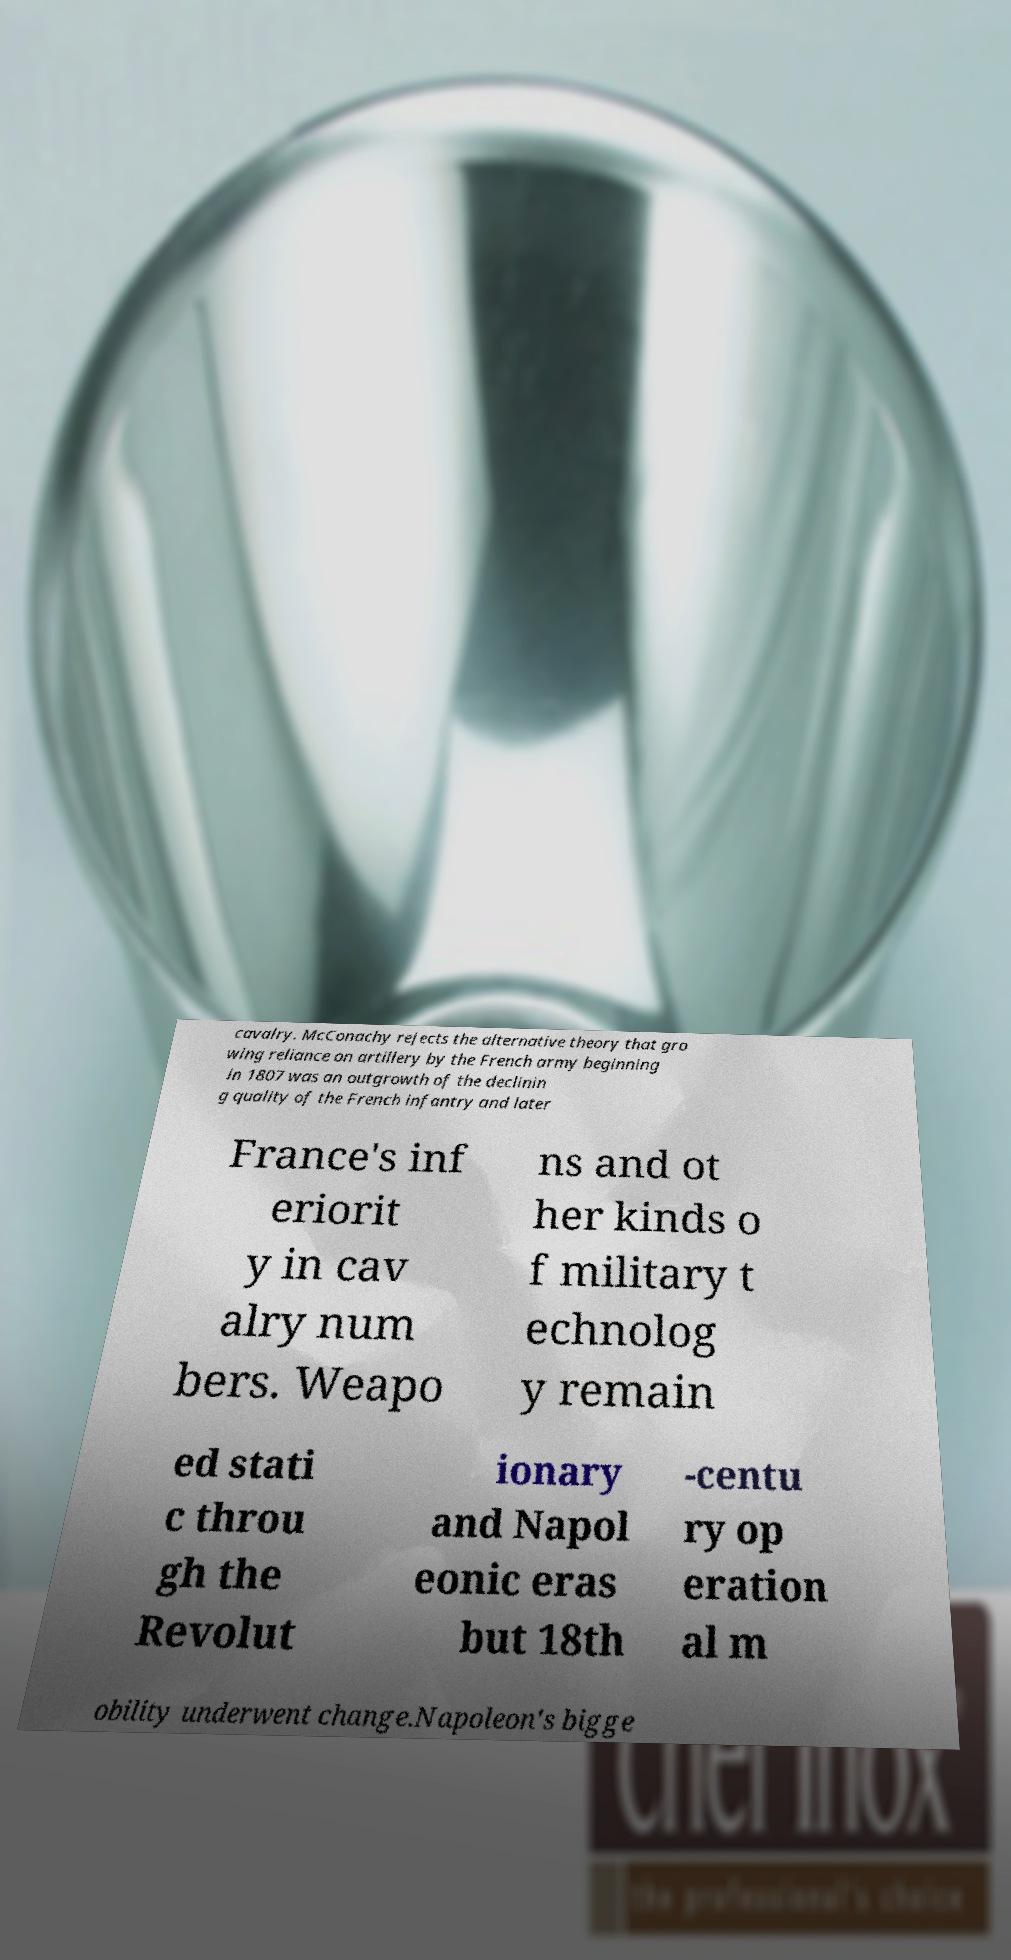I need the written content from this picture converted into text. Can you do that? cavalry. McConachy rejects the alternative theory that gro wing reliance on artillery by the French army beginning in 1807 was an outgrowth of the declinin g quality of the French infantry and later France's inf eriorit y in cav alry num bers. Weapo ns and ot her kinds o f military t echnolog y remain ed stati c throu gh the Revolut ionary and Napol eonic eras but 18th -centu ry op eration al m obility underwent change.Napoleon's bigge 